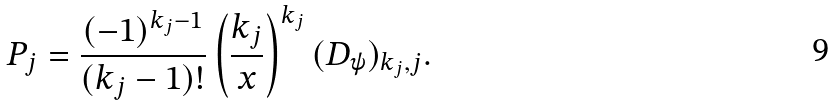<formula> <loc_0><loc_0><loc_500><loc_500>P _ { j } = \frac { ( - 1 ) ^ { k _ { j } - 1 } } { ( k _ { j } - 1 ) ! } \left ( \frac { k _ { j } } { x } \right ) ^ { k _ { j } } ( D _ { \psi } ) _ { k _ { j } , j } .</formula> 